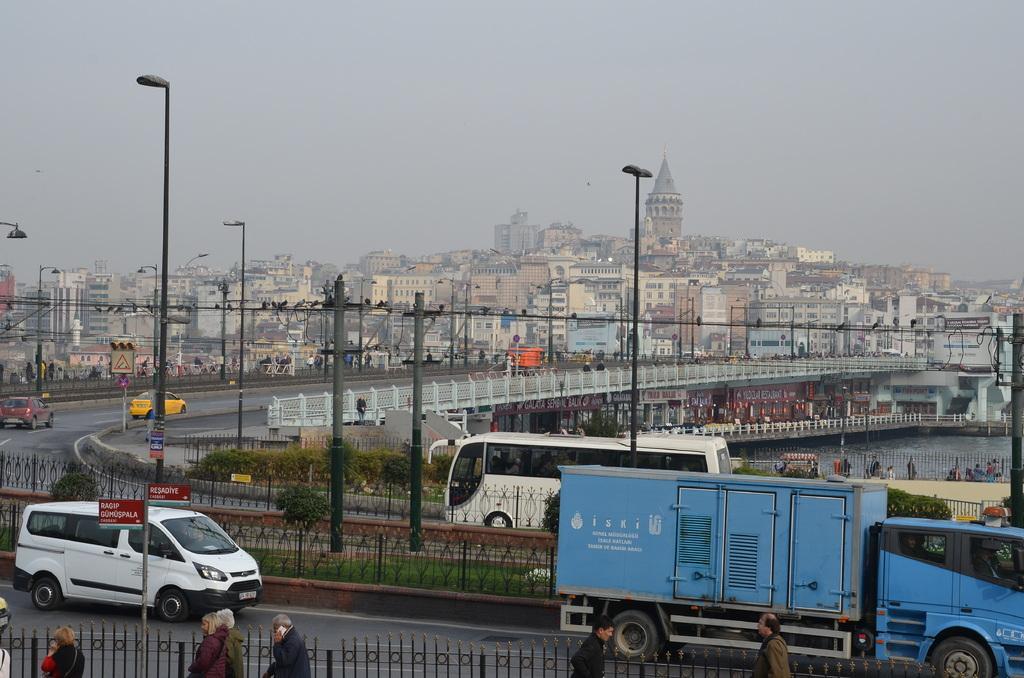Please provide a concise description of this image. In this picture there are few vehicles on the road and there are few poles and people beside it and there are few birds,a bridge and buildings in the background. 